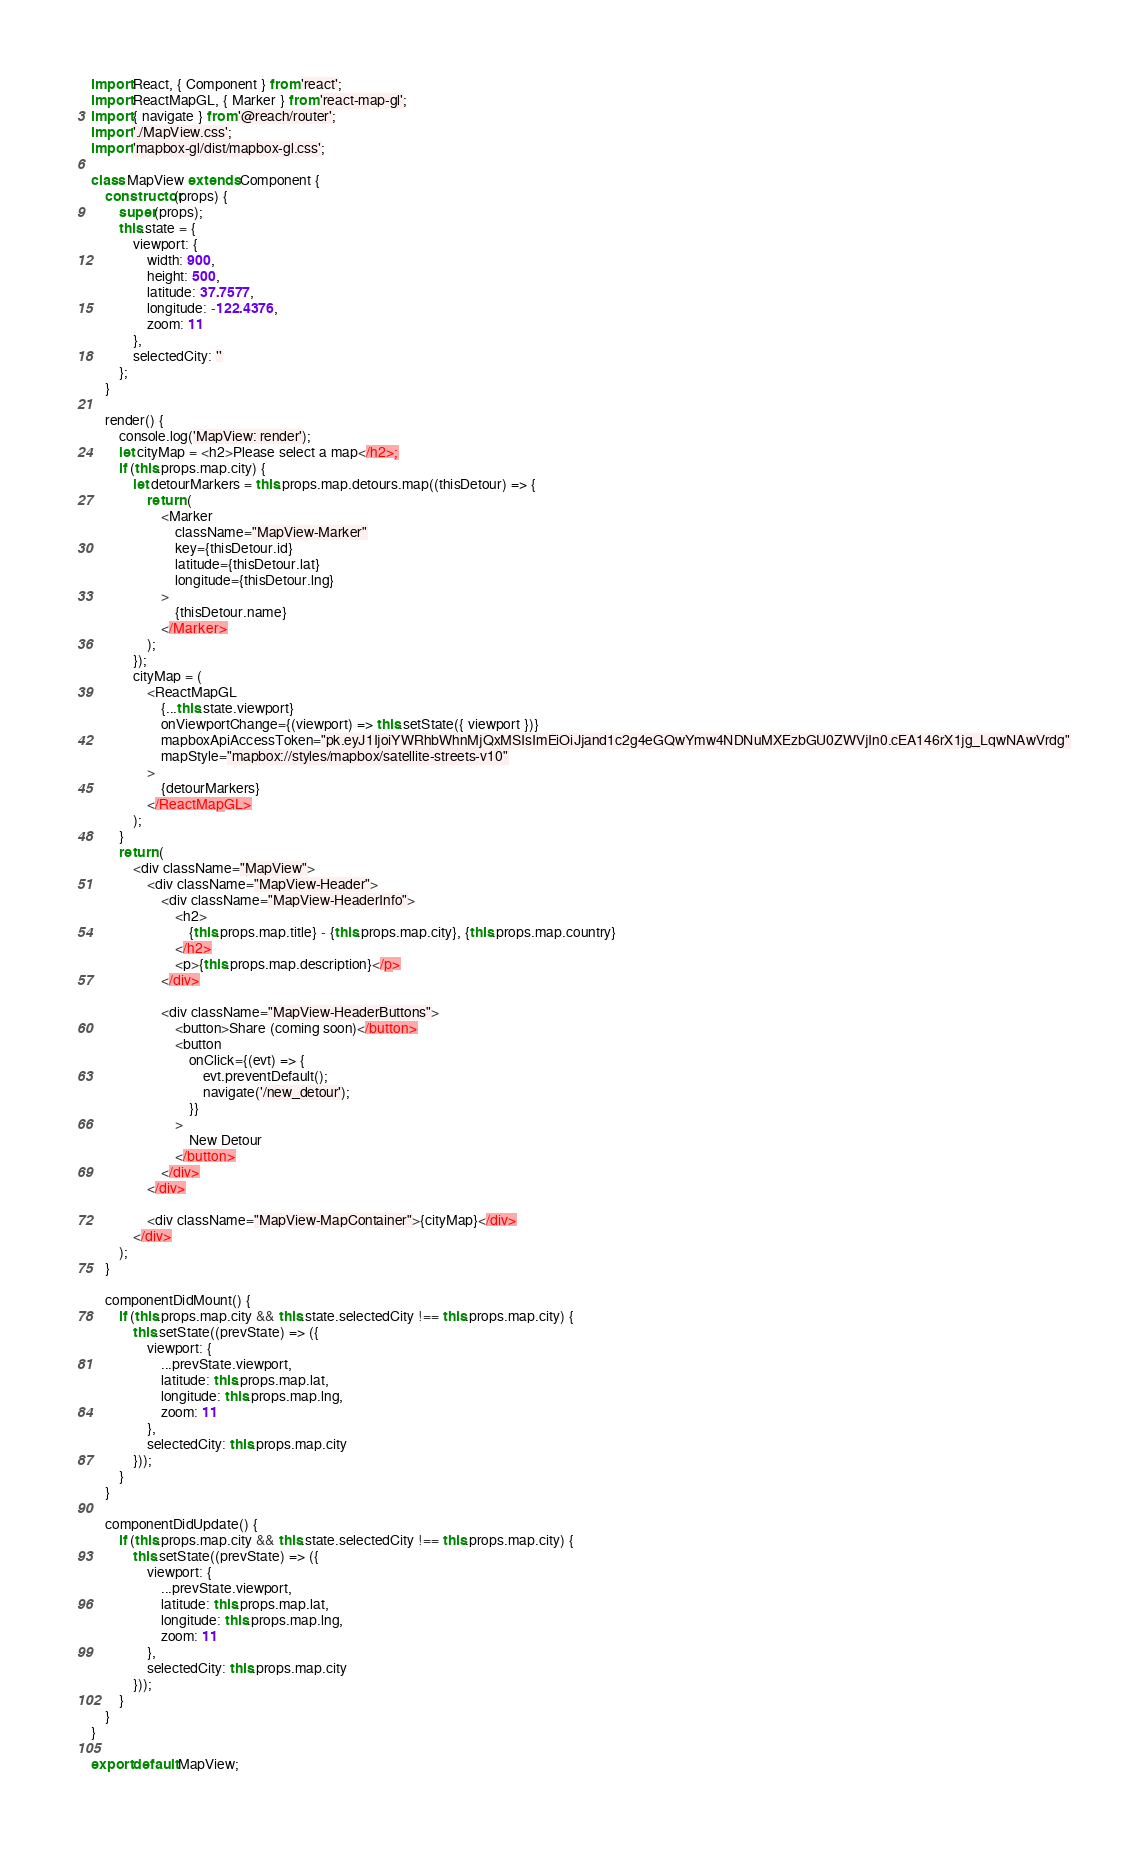<code> <loc_0><loc_0><loc_500><loc_500><_JavaScript_>import React, { Component } from 'react';
import ReactMapGL, { Marker } from 'react-map-gl';
import { navigate } from '@reach/router';
import './MapView.css';
import 'mapbox-gl/dist/mapbox-gl.css';

class MapView extends Component {
	constructor(props) {
		super(props);
		this.state = {
			viewport: {
				width: 900,
				height: 500,
				latitude: 37.7577,
				longitude: -122.4376,
				zoom: 11
			},
			selectedCity: ''
		};
	}

	render() {
		console.log('MapView: render');
		let cityMap = <h2>Please select a map</h2>;
		if (this.props.map.city) {
			let detourMarkers = this.props.map.detours.map((thisDetour) => {
				return (
					<Marker
						className="MapView-Marker"
						key={thisDetour.id}
						latitude={thisDetour.lat}
						longitude={thisDetour.lng}
					>
						{thisDetour.name}
					</Marker>
				);
			});
			cityMap = (
				<ReactMapGL
					{...this.state.viewport}
					onViewportChange={(viewport) => this.setState({ viewport })}
					mapboxApiAccessToken="pk.eyJ1IjoiYWRhbWhnMjQxMSIsImEiOiJjand1c2g4eGQwYmw4NDNuMXEzbGU0ZWVjIn0.cEA146rX1jg_LqwNAwVrdg"
					mapStyle="mapbox://styles/mapbox/satellite-streets-v10"
				>
					{detourMarkers}
				</ReactMapGL>
			);
		}
		return (
			<div className="MapView">
				<div className="MapView-Header">
					<div className="MapView-HeaderInfo">
						<h2>
							{this.props.map.title} - {this.props.map.city}, {this.props.map.country}
						</h2>
						<p>{this.props.map.description}</p>
					</div>

					<div className="MapView-HeaderButtons">
						<button>Share (coming soon)</button>
						<button
							onClick={(evt) => {
								evt.preventDefault();
								navigate('/new_detour');
							}}
						>
							New Detour
						</button>
					</div>
				</div>

				<div className="MapView-MapContainer">{cityMap}</div>
			</div>
		);
	}

	componentDidMount() {
		if (this.props.map.city && this.state.selectedCity !== this.props.map.city) {
			this.setState((prevState) => ({
				viewport: {
					...prevState.viewport,
					latitude: this.props.map.lat,
					longitude: this.props.map.lng,
					zoom: 11
				},
				selectedCity: this.props.map.city
			}));
		}
	}

	componentDidUpdate() {
		if (this.props.map.city && this.state.selectedCity !== this.props.map.city) {
			this.setState((prevState) => ({
				viewport: {
					...prevState.viewport,
					latitude: this.props.map.lat,
					longitude: this.props.map.lng,
					zoom: 11
				},
				selectedCity: this.props.map.city
			}));
		}
	}
}

export default MapView;
</code> 